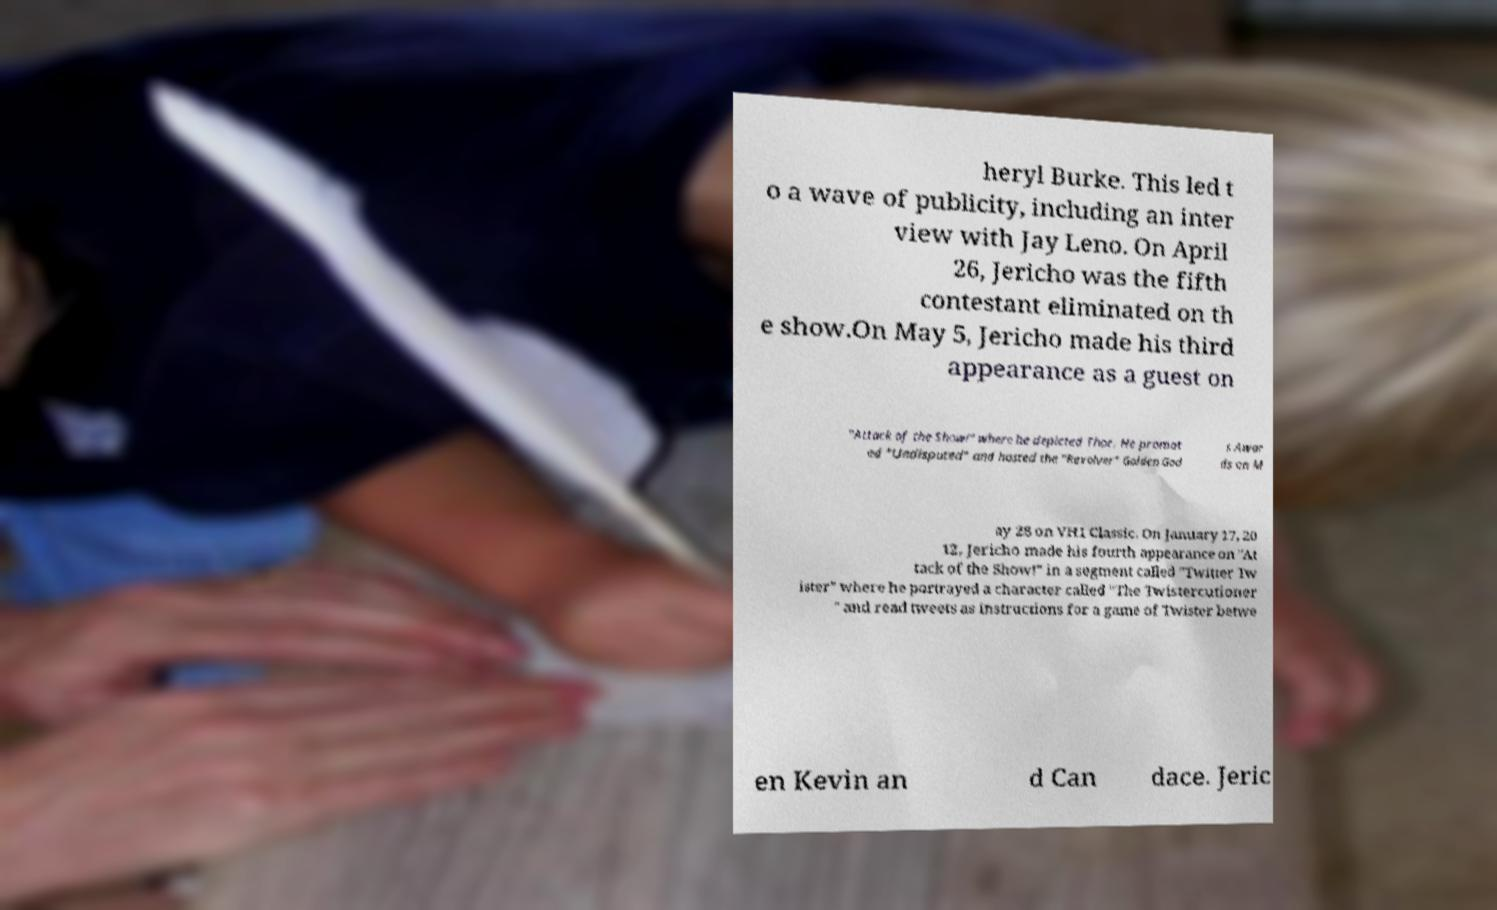Can you read and provide the text displayed in the image?This photo seems to have some interesting text. Can you extract and type it out for me? heryl Burke. This led t o a wave of publicity, including an inter view with Jay Leno. On April 26, Jericho was the fifth contestant eliminated on th e show.On May 5, Jericho made his third appearance as a guest on "Attack of the Show!" where he depicted Thor. He promot ed "Undisputed" and hosted the "Revolver" Golden God s Awar ds on M ay 28 on VH1 Classic. On January 17, 20 12, Jericho made his fourth appearance on "At tack of the Show!" in a segment called "Twitter Tw ister" where he portrayed a character called "The Twistercutioner " and read tweets as instructions for a game of Twister betwe en Kevin an d Can dace. Jeric 